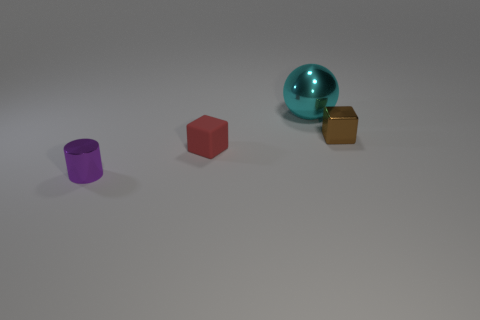Subtract all balls. How many objects are left? 3 Subtract all brown blocks. How many blocks are left? 1 Subtract 1 cubes. How many cubes are left? 1 Add 2 tiny purple metal cylinders. How many tiny purple metal cylinders exist? 3 Add 3 purple metal cylinders. How many objects exist? 7 Subtract 0 red spheres. How many objects are left? 4 Subtract all green balls. Subtract all cyan cylinders. How many balls are left? 1 Subtract all cyan cylinders. How many red blocks are left? 1 Subtract all small red things. Subtract all tiny brown blocks. How many objects are left? 2 Add 3 shiny cylinders. How many shiny cylinders are left? 4 